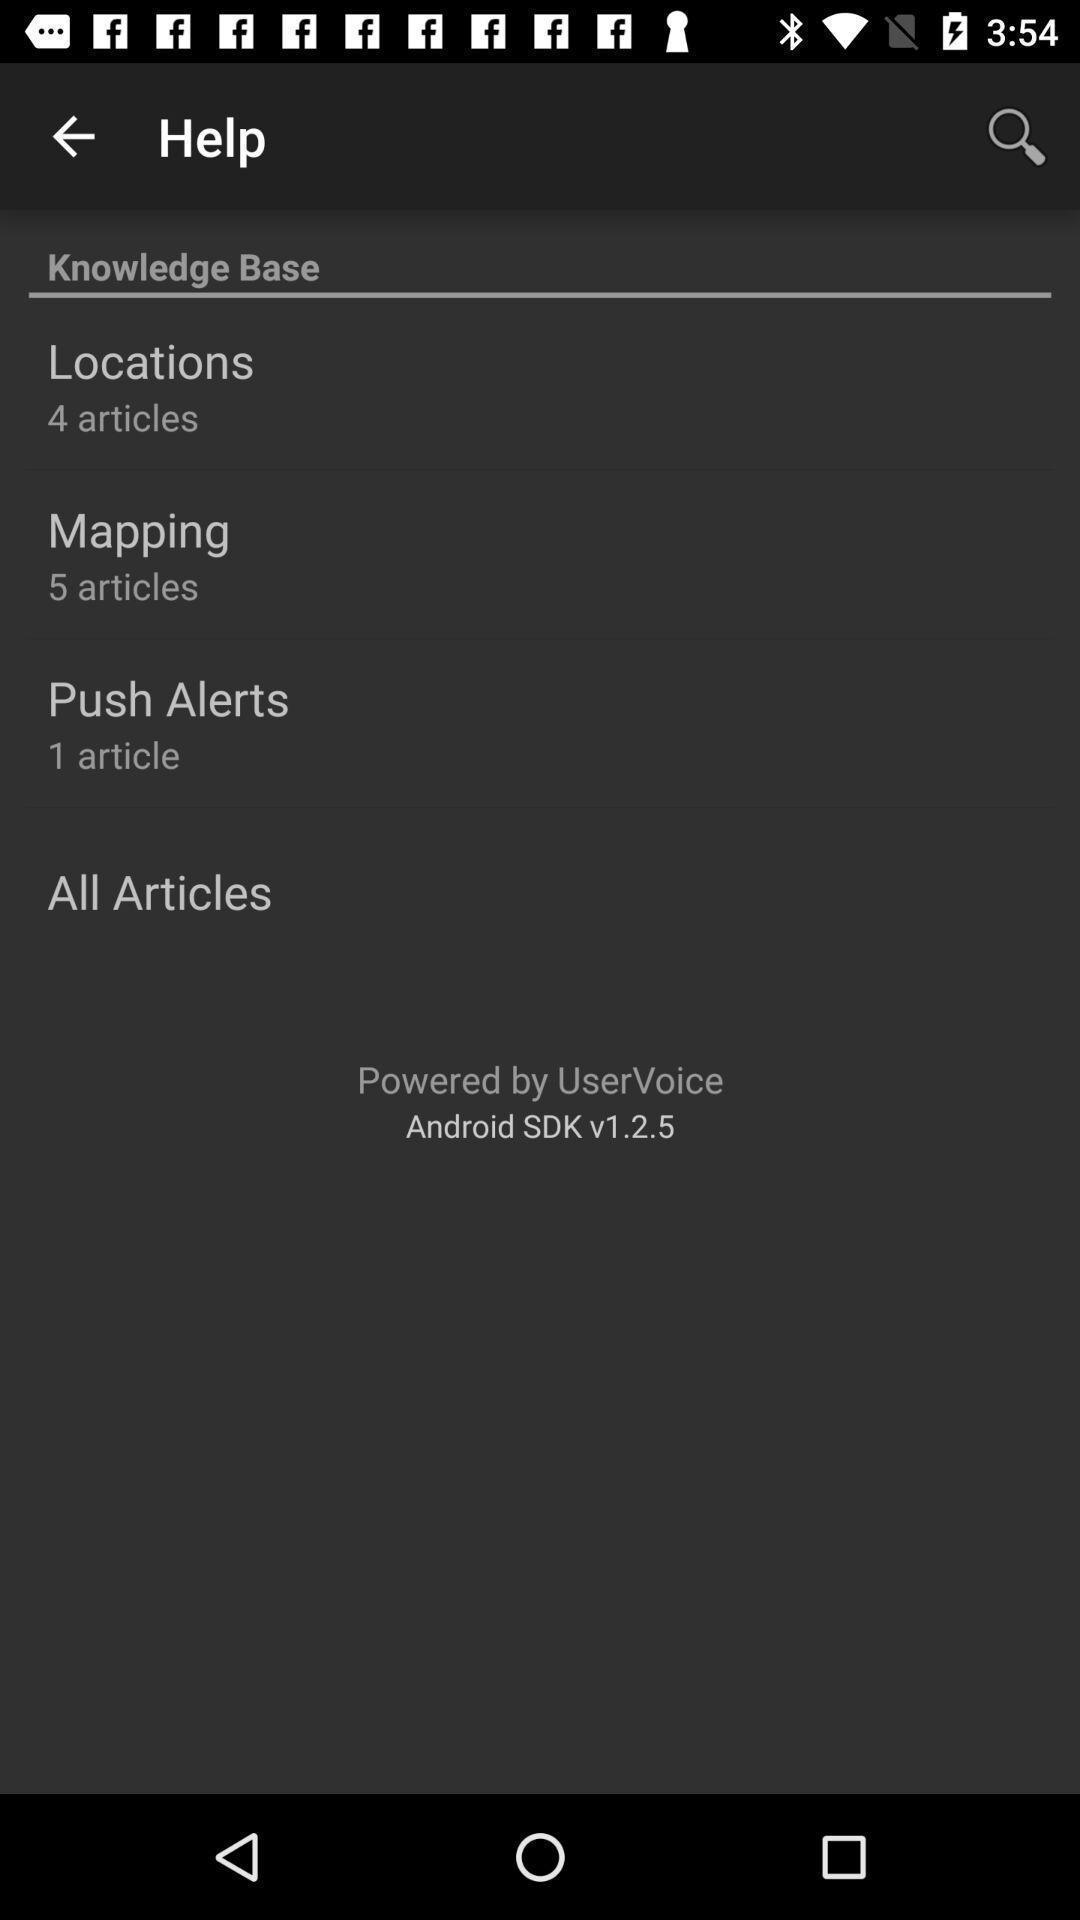What is the overall content of this screenshot? Page showing options in a weather forecast app. 